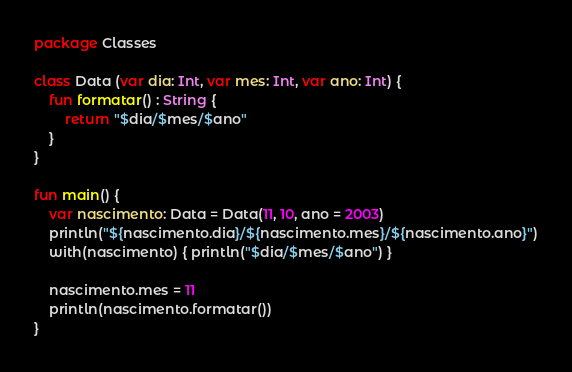<code> <loc_0><loc_0><loc_500><loc_500><_Kotlin_>package Classes

class Data (var dia: Int, var mes: Int, var ano: Int) {
    fun formatar() : String {
        return "$dia/$mes/$ano"
    }
}

fun main() {
    var nascimento: Data = Data(11, 10, ano = 2003)
    println("${nascimento.dia}/${nascimento.mes}/${nascimento.ano}")
    with(nascimento) { println("$dia/$mes/$ano") }

    nascimento.mes = 11
    println(nascimento.formatar())
}</code> 